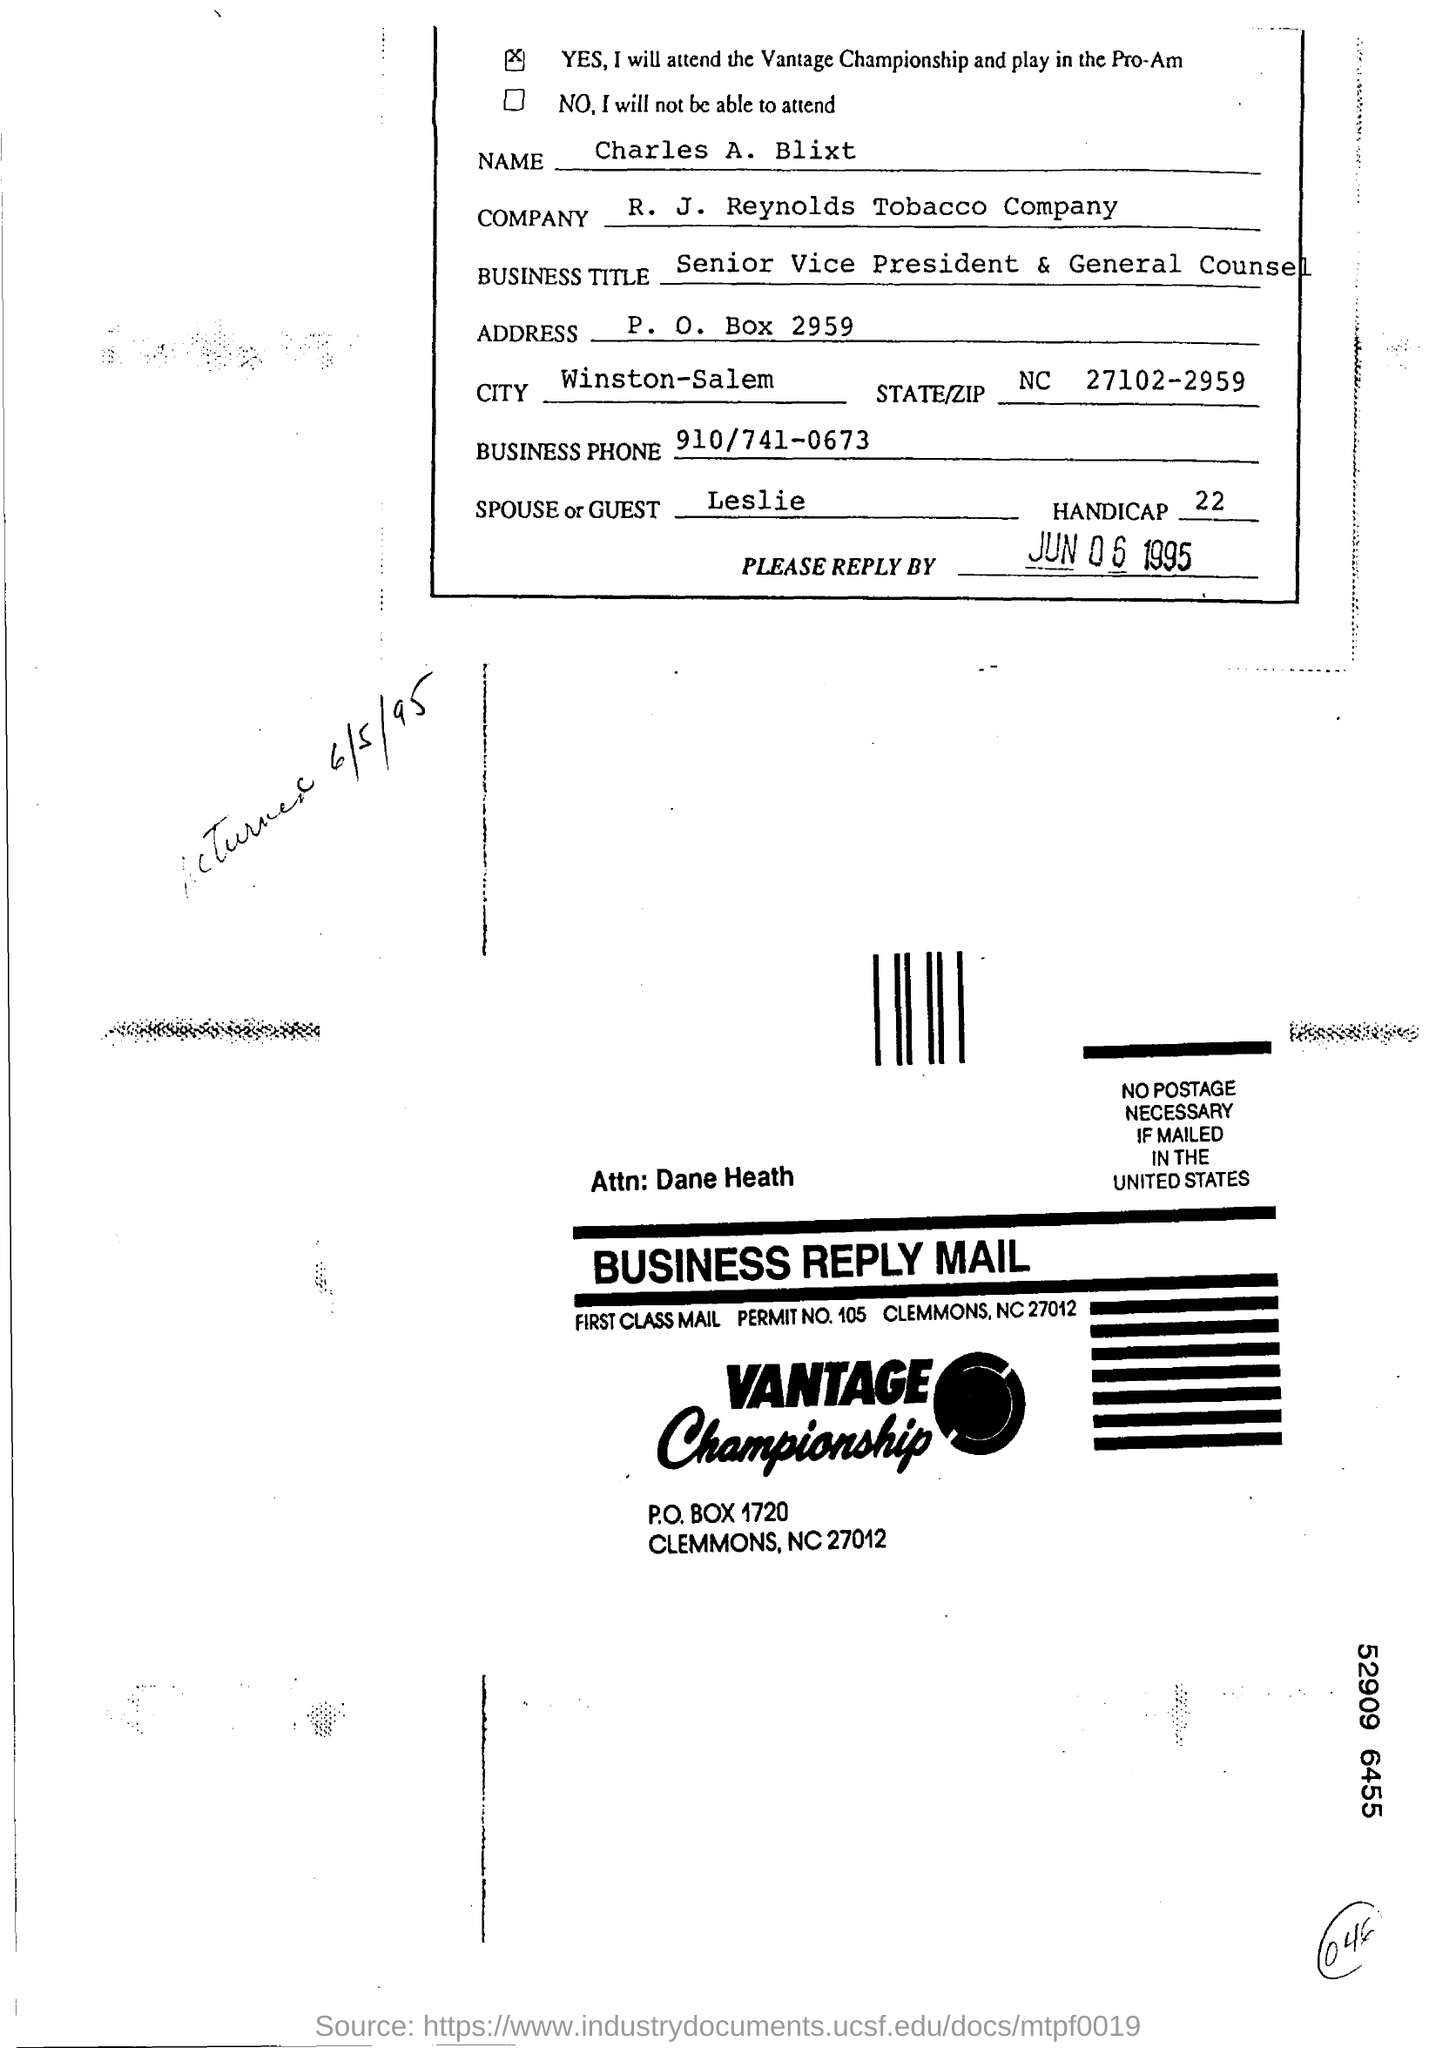List a handful of essential elements in this visual. The spouse or guest's name is Leslie. Charles A. Blixt holds the position of Senior Vice President & General Counsel in his business. The business telephone number is 910/741-0673. Charles A. Blixt is the Senior Vice President and General Counsel of a business. 